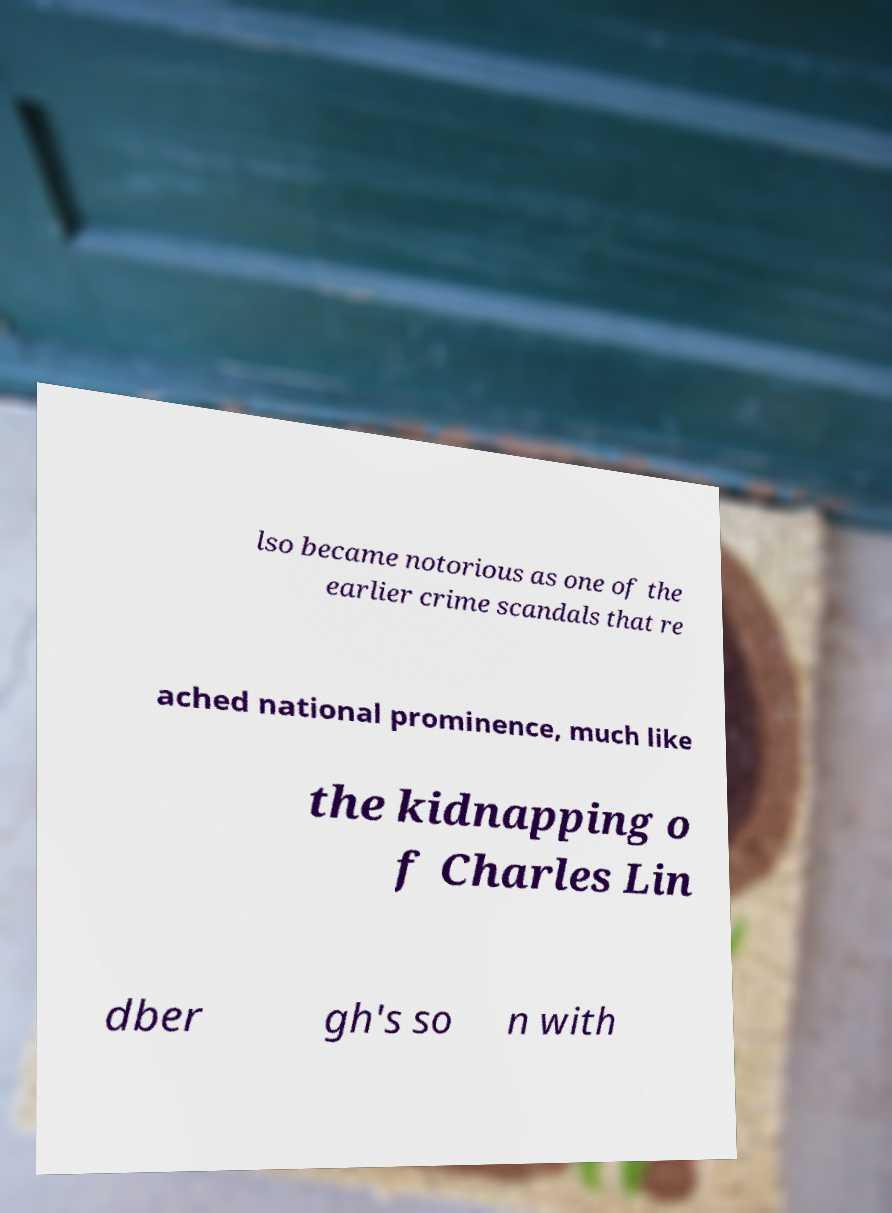Could you assist in decoding the text presented in this image and type it out clearly? lso became notorious as one of the earlier crime scandals that re ached national prominence, much like the kidnapping o f Charles Lin dber gh's so n with 